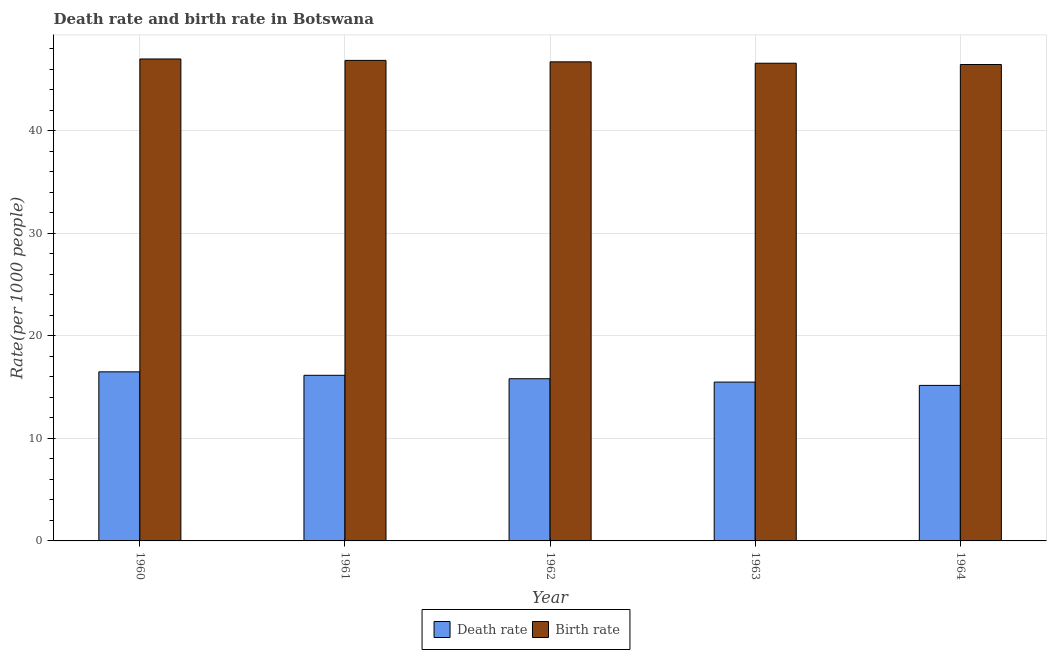How many groups of bars are there?
Provide a succinct answer. 5. Are the number of bars per tick equal to the number of legend labels?
Keep it short and to the point. Yes. Are the number of bars on each tick of the X-axis equal?
Make the answer very short. Yes. How many bars are there on the 4th tick from the left?
Ensure brevity in your answer.  2. What is the label of the 2nd group of bars from the left?
Provide a short and direct response. 1961. What is the birth rate in 1963?
Offer a terse response. 46.58. Across all years, what is the maximum birth rate?
Your answer should be very brief. 46.99. Across all years, what is the minimum death rate?
Your answer should be very brief. 15.16. In which year was the death rate maximum?
Ensure brevity in your answer.  1960. In which year was the death rate minimum?
Provide a short and direct response. 1964. What is the total birth rate in the graph?
Make the answer very short. 233.59. What is the difference between the birth rate in 1962 and that in 1964?
Keep it short and to the point. 0.26. What is the difference between the birth rate in 1960 and the death rate in 1962?
Provide a short and direct response. 0.28. What is the average birth rate per year?
Give a very brief answer. 46.72. What is the ratio of the birth rate in 1961 to that in 1964?
Offer a very short reply. 1.01. Is the difference between the death rate in 1962 and 1964 greater than the difference between the birth rate in 1962 and 1964?
Keep it short and to the point. No. What is the difference between the highest and the second highest death rate?
Your answer should be compact. 0.34. What is the difference between the highest and the lowest birth rate?
Keep it short and to the point. 0.54. In how many years, is the birth rate greater than the average birth rate taken over all years?
Keep it short and to the point. 2. What does the 2nd bar from the left in 1960 represents?
Ensure brevity in your answer.  Birth rate. What does the 1st bar from the right in 1960 represents?
Make the answer very short. Birth rate. How many years are there in the graph?
Your answer should be very brief. 5. Are the values on the major ticks of Y-axis written in scientific E-notation?
Your answer should be very brief. No. Does the graph contain any zero values?
Keep it short and to the point. No. Where does the legend appear in the graph?
Your answer should be very brief. Bottom center. What is the title of the graph?
Give a very brief answer. Death rate and birth rate in Botswana. Does "Food" appear as one of the legend labels in the graph?
Give a very brief answer. No. What is the label or title of the Y-axis?
Your answer should be compact. Rate(per 1000 people). What is the Rate(per 1000 people) of Death rate in 1960?
Ensure brevity in your answer.  16.49. What is the Rate(per 1000 people) of Birth rate in 1960?
Offer a terse response. 46.99. What is the Rate(per 1000 people) of Death rate in 1961?
Offer a terse response. 16.15. What is the Rate(per 1000 people) in Birth rate in 1961?
Provide a succinct answer. 46.85. What is the Rate(per 1000 people) in Death rate in 1962?
Your answer should be very brief. 15.81. What is the Rate(per 1000 people) in Birth rate in 1962?
Offer a very short reply. 46.71. What is the Rate(per 1000 people) of Death rate in 1963?
Make the answer very short. 15.49. What is the Rate(per 1000 people) in Birth rate in 1963?
Give a very brief answer. 46.58. What is the Rate(per 1000 people) in Death rate in 1964?
Your answer should be very brief. 15.16. What is the Rate(per 1000 people) of Birth rate in 1964?
Offer a very short reply. 46.45. Across all years, what is the maximum Rate(per 1000 people) of Death rate?
Give a very brief answer. 16.49. Across all years, what is the maximum Rate(per 1000 people) of Birth rate?
Give a very brief answer. 46.99. Across all years, what is the minimum Rate(per 1000 people) in Death rate?
Offer a very short reply. 15.16. Across all years, what is the minimum Rate(per 1000 people) in Birth rate?
Your answer should be compact. 46.45. What is the total Rate(per 1000 people) in Death rate in the graph?
Make the answer very short. 79.1. What is the total Rate(per 1000 people) in Birth rate in the graph?
Your response must be concise. 233.59. What is the difference between the Rate(per 1000 people) in Death rate in 1960 and that in 1961?
Your answer should be very brief. 0.34. What is the difference between the Rate(per 1000 people) in Birth rate in 1960 and that in 1961?
Ensure brevity in your answer.  0.14. What is the difference between the Rate(per 1000 people) in Death rate in 1960 and that in 1962?
Provide a succinct answer. 0.67. What is the difference between the Rate(per 1000 people) in Birth rate in 1960 and that in 1962?
Your answer should be very brief. 0.28. What is the difference between the Rate(per 1000 people) in Death rate in 1960 and that in 1963?
Give a very brief answer. 1. What is the difference between the Rate(per 1000 people) of Birth rate in 1960 and that in 1963?
Offer a terse response. 0.41. What is the difference between the Rate(per 1000 people) of Death rate in 1960 and that in 1964?
Give a very brief answer. 1.32. What is the difference between the Rate(per 1000 people) in Birth rate in 1960 and that in 1964?
Make the answer very short. 0.54. What is the difference between the Rate(per 1000 people) in Death rate in 1961 and that in 1962?
Provide a short and direct response. 0.33. What is the difference between the Rate(per 1000 people) in Birth rate in 1961 and that in 1962?
Give a very brief answer. 0.14. What is the difference between the Rate(per 1000 people) of Death rate in 1961 and that in 1963?
Ensure brevity in your answer.  0.66. What is the difference between the Rate(per 1000 people) of Birth rate in 1961 and that in 1963?
Provide a short and direct response. 0.28. What is the difference between the Rate(per 1000 people) in Birth rate in 1961 and that in 1964?
Your answer should be very brief. 0.4. What is the difference between the Rate(per 1000 people) in Death rate in 1962 and that in 1963?
Provide a short and direct response. 0.33. What is the difference between the Rate(per 1000 people) of Birth rate in 1962 and that in 1963?
Provide a succinct answer. 0.14. What is the difference between the Rate(per 1000 people) of Death rate in 1962 and that in 1964?
Ensure brevity in your answer.  0.65. What is the difference between the Rate(per 1000 people) in Birth rate in 1962 and that in 1964?
Provide a short and direct response. 0.26. What is the difference between the Rate(per 1000 people) of Death rate in 1963 and that in 1964?
Offer a very short reply. 0.32. What is the difference between the Rate(per 1000 people) of Birth rate in 1963 and that in 1964?
Your answer should be very brief. 0.12. What is the difference between the Rate(per 1000 people) of Death rate in 1960 and the Rate(per 1000 people) of Birth rate in 1961?
Offer a terse response. -30.37. What is the difference between the Rate(per 1000 people) of Death rate in 1960 and the Rate(per 1000 people) of Birth rate in 1962?
Make the answer very short. -30.23. What is the difference between the Rate(per 1000 people) in Death rate in 1960 and the Rate(per 1000 people) in Birth rate in 1963?
Your response must be concise. -30.09. What is the difference between the Rate(per 1000 people) in Death rate in 1960 and the Rate(per 1000 people) in Birth rate in 1964?
Your response must be concise. -29.97. What is the difference between the Rate(per 1000 people) of Death rate in 1961 and the Rate(per 1000 people) of Birth rate in 1962?
Provide a short and direct response. -30.57. What is the difference between the Rate(per 1000 people) of Death rate in 1961 and the Rate(per 1000 people) of Birth rate in 1963?
Keep it short and to the point. -30.43. What is the difference between the Rate(per 1000 people) in Death rate in 1961 and the Rate(per 1000 people) in Birth rate in 1964?
Offer a very short reply. -30.3. What is the difference between the Rate(per 1000 people) in Death rate in 1962 and the Rate(per 1000 people) in Birth rate in 1963?
Your answer should be compact. -30.76. What is the difference between the Rate(per 1000 people) in Death rate in 1962 and the Rate(per 1000 people) in Birth rate in 1964?
Your answer should be compact. -30.64. What is the difference between the Rate(per 1000 people) in Death rate in 1963 and the Rate(per 1000 people) in Birth rate in 1964?
Give a very brief answer. -30.96. What is the average Rate(per 1000 people) of Death rate per year?
Make the answer very short. 15.82. What is the average Rate(per 1000 people) of Birth rate per year?
Ensure brevity in your answer.  46.72. In the year 1960, what is the difference between the Rate(per 1000 people) of Death rate and Rate(per 1000 people) of Birth rate?
Keep it short and to the point. -30.51. In the year 1961, what is the difference between the Rate(per 1000 people) in Death rate and Rate(per 1000 people) in Birth rate?
Offer a very short reply. -30.71. In the year 1962, what is the difference between the Rate(per 1000 people) in Death rate and Rate(per 1000 people) in Birth rate?
Your answer should be compact. -30.9. In the year 1963, what is the difference between the Rate(per 1000 people) in Death rate and Rate(per 1000 people) in Birth rate?
Make the answer very short. -31.09. In the year 1964, what is the difference between the Rate(per 1000 people) of Death rate and Rate(per 1000 people) of Birth rate?
Ensure brevity in your answer.  -31.29. What is the ratio of the Rate(per 1000 people) of Death rate in 1960 to that in 1961?
Give a very brief answer. 1.02. What is the ratio of the Rate(per 1000 people) of Death rate in 1960 to that in 1962?
Your response must be concise. 1.04. What is the ratio of the Rate(per 1000 people) in Death rate in 1960 to that in 1963?
Make the answer very short. 1.06. What is the ratio of the Rate(per 1000 people) of Birth rate in 1960 to that in 1963?
Your response must be concise. 1.01. What is the ratio of the Rate(per 1000 people) in Death rate in 1960 to that in 1964?
Give a very brief answer. 1.09. What is the ratio of the Rate(per 1000 people) of Birth rate in 1960 to that in 1964?
Keep it short and to the point. 1.01. What is the ratio of the Rate(per 1000 people) in Death rate in 1961 to that in 1962?
Provide a short and direct response. 1.02. What is the ratio of the Rate(per 1000 people) in Birth rate in 1961 to that in 1962?
Keep it short and to the point. 1. What is the ratio of the Rate(per 1000 people) of Death rate in 1961 to that in 1963?
Make the answer very short. 1.04. What is the ratio of the Rate(per 1000 people) in Birth rate in 1961 to that in 1963?
Provide a short and direct response. 1.01. What is the ratio of the Rate(per 1000 people) of Death rate in 1961 to that in 1964?
Provide a succinct answer. 1.06. What is the ratio of the Rate(per 1000 people) in Birth rate in 1961 to that in 1964?
Your answer should be compact. 1.01. What is the ratio of the Rate(per 1000 people) of Death rate in 1962 to that in 1963?
Your response must be concise. 1.02. What is the ratio of the Rate(per 1000 people) of Birth rate in 1962 to that in 1963?
Keep it short and to the point. 1. What is the ratio of the Rate(per 1000 people) of Death rate in 1962 to that in 1964?
Your response must be concise. 1.04. What is the ratio of the Rate(per 1000 people) in Birth rate in 1962 to that in 1964?
Your answer should be very brief. 1.01. What is the ratio of the Rate(per 1000 people) of Death rate in 1963 to that in 1964?
Offer a terse response. 1.02. What is the difference between the highest and the second highest Rate(per 1000 people) of Death rate?
Offer a terse response. 0.34. What is the difference between the highest and the second highest Rate(per 1000 people) of Birth rate?
Make the answer very short. 0.14. What is the difference between the highest and the lowest Rate(per 1000 people) of Death rate?
Offer a very short reply. 1.32. What is the difference between the highest and the lowest Rate(per 1000 people) of Birth rate?
Offer a terse response. 0.54. 